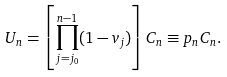Convert formula to latex. <formula><loc_0><loc_0><loc_500><loc_500>U _ { n } = \left [ \prod _ { j = j _ { 0 } } ^ { n - 1 } ( 1 - v _ { j } ) \right ] C _ { n } \equiv p _ { n } C _ { n } .</formula> 